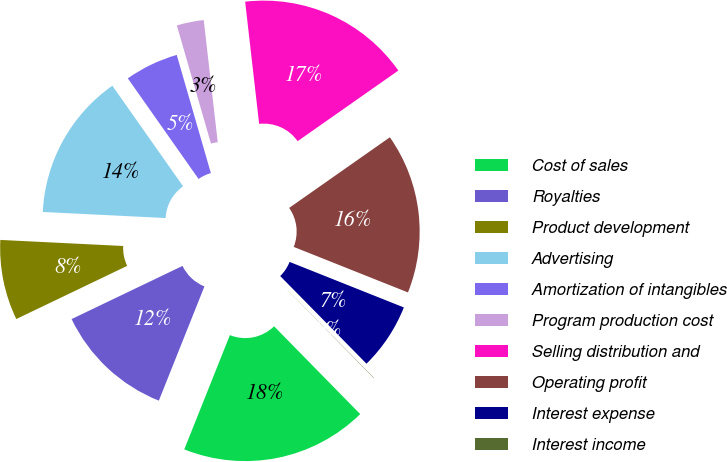<chart> <loc_0><loc_0><loc_500><loc_500><pie_chart><fcel>Cost of sales<fcel>Royalties<fcel>Product development<fcel>Advertising<fcel>Amortization of intangibles<fcel>Program production cost<fcel>Selling distribution and<fcel>Operating profit<fcel>Interest expense<fcel>Interest income<nl><fcel>18.39%<fcel>11.84%<fcel>7.9%<fcel>14.46%<fcel>5.28%<fcel>2.66%<fcel>17.08%<fcel>15.77%<fcel>6.59%<fcel>0.03%<nl></chart> 